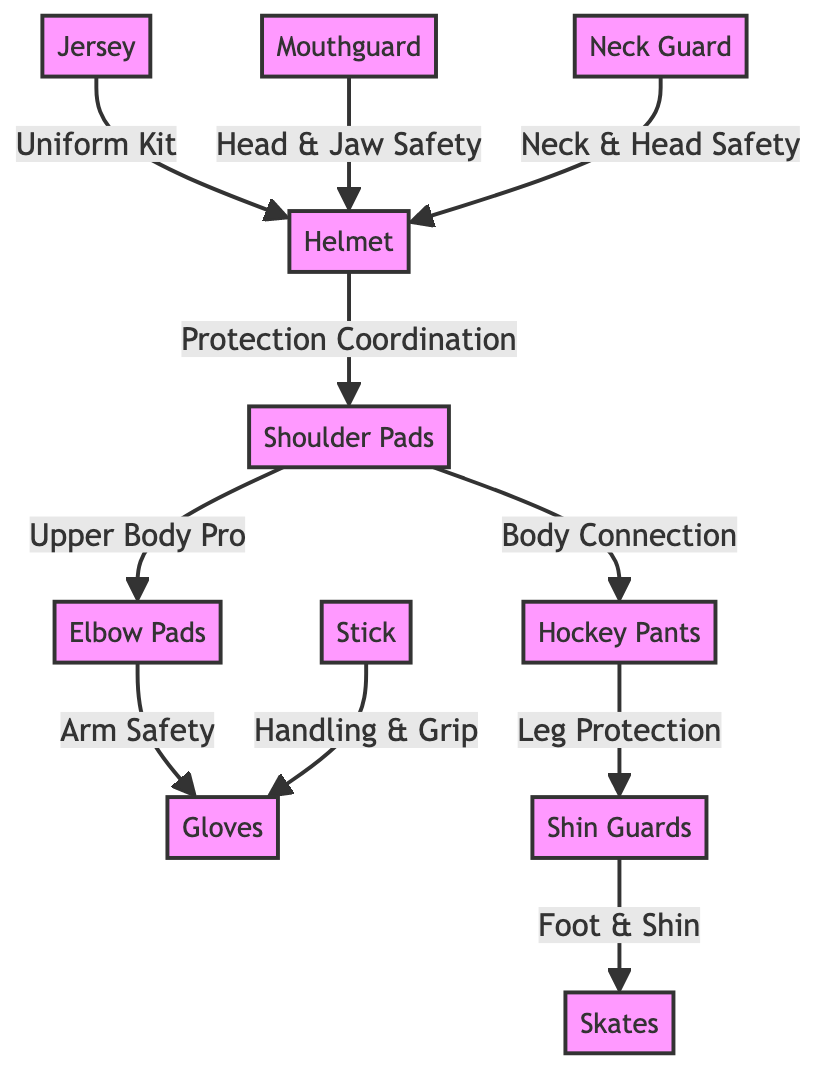What is the first node listed in the diagram? The first node listed is 'Helmet'. This is determined by examining the order of the nodes in the diagram.
Answer: Helmet How many protective gear items are there in total? There are 11 items listed in the diagram. This is counted by enumerating each node representing the gear: Helmet, Shoulder Pads, Elbow Pads, Gloves, Pants, Shin Guards, Skates, Stick, Jersey, Mouthguard, and Neck Guard.
Answer: 11 Which gear is directly connected to the Helmet? The gear directly connected to the Helmet is 'Shoulder Pads'. This can be seen by following the arrow from the Helmet node to the Shoulder Pads node.
Answer: Shoulder Pads What type of safety does the Mouthguard provide? The Mouthguard provides 'Head & Jaw Safety'. This is indicated by the label attached to the arrow connecting it to the Helmet node.
Answer: Head & Jaw Safety Which protective gear connects to both the Elbow Pads and Gloves? The protective gear that connects to both the Elbow Pads and Gloves is 'Shoulder Pads'. First, observe that the Elbow Pads link to Gloves, and the Shoulder Pads connect to Elbow Pads; thus, Shoulder Pads relate to both gear types.
Answer: Shoulder Pads What is the relationship between Pants and Shin Guards? The relationship is 'Leg Protection'. This is identified by the label on the arrow connecting the Pants node to the Shin Guards node, indicating the purpose of the connection.
Answer: Leg Protection Is there any gear that directly connects to the Stick? Yes, the Stick directly connects to 'Gloves'. This connection is visible in the diagram, where an arrow points from Stick to Gloves.
Answer: Gloves Which gear is important for neck safety? The gear important for neck safety is 'Neck Guard'. This is stated explicitly in the diagram where the Neck Guard is linked to the Helmet node.
Answer: Neck Guard Which gear provides protection for both the foot and shin? The gear that provides protection for both the foot and shin is 'Skates'. This can be verified by examining the arrow labeled 'Foot & Shin' that connects the Shin Guards to the Skates.
Answer: Skates 